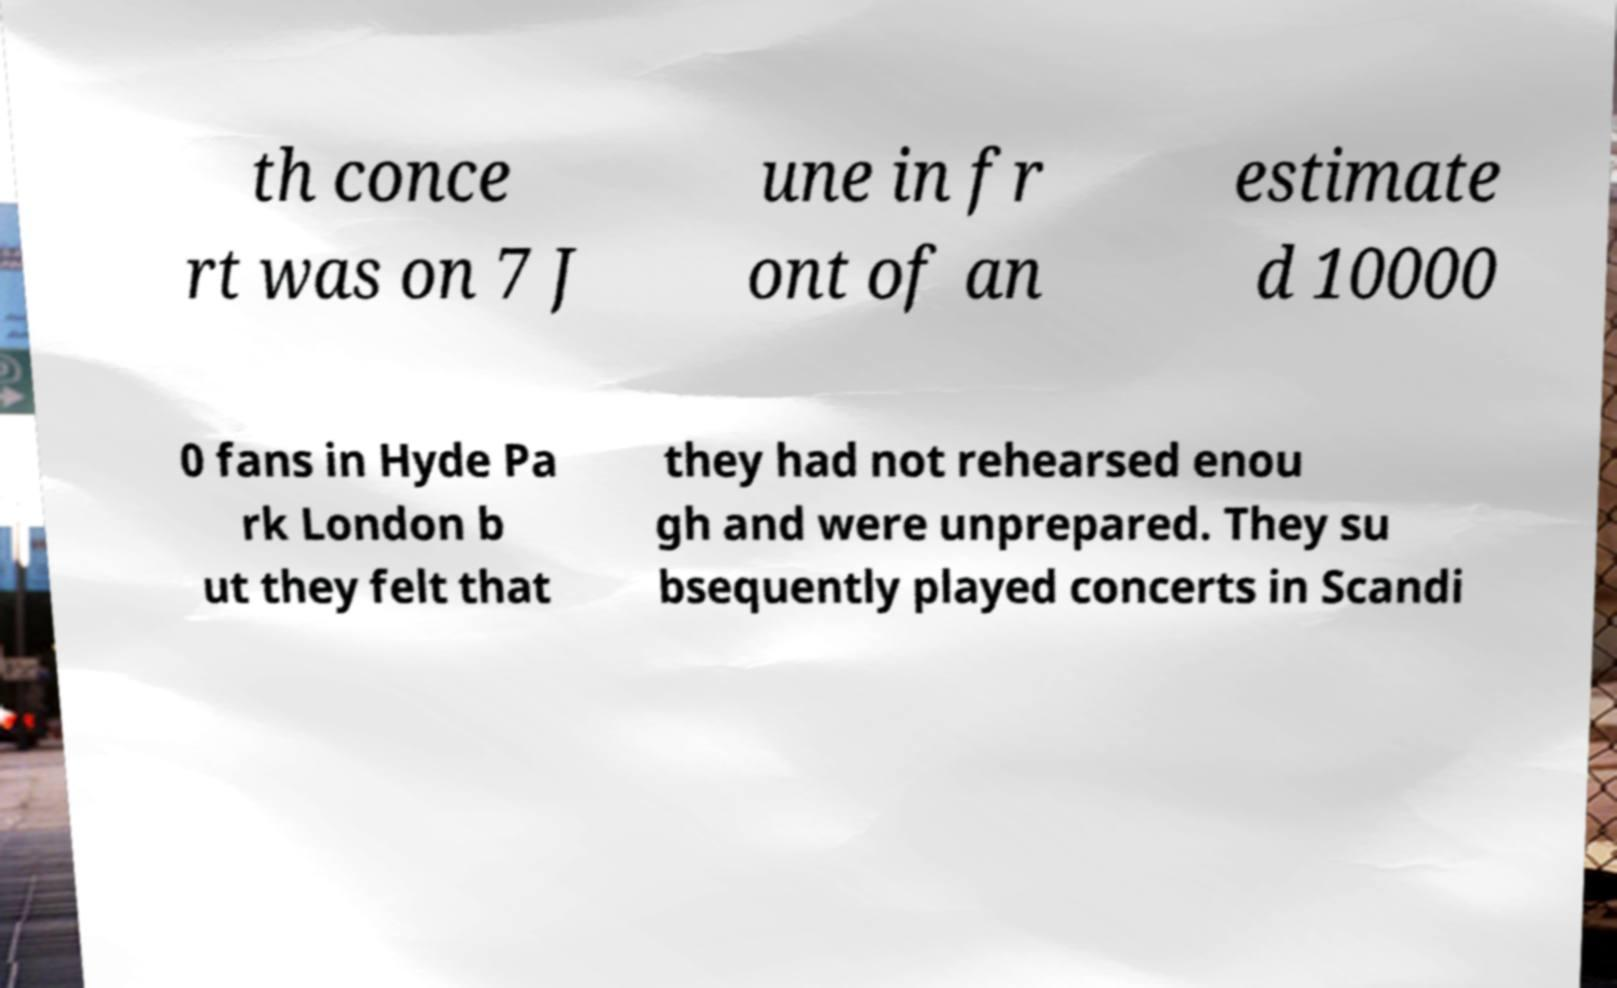What messages or text are displayed in this image? I need them in a readable, typed format. th conce rt was on 7 J une in fr ont of an estimate d 10000 0 fans in Hyde Pa rk London b ut they felt that they had not rehearsed enou gh and were unprepared. They su bsequently played concerts in Scandi 